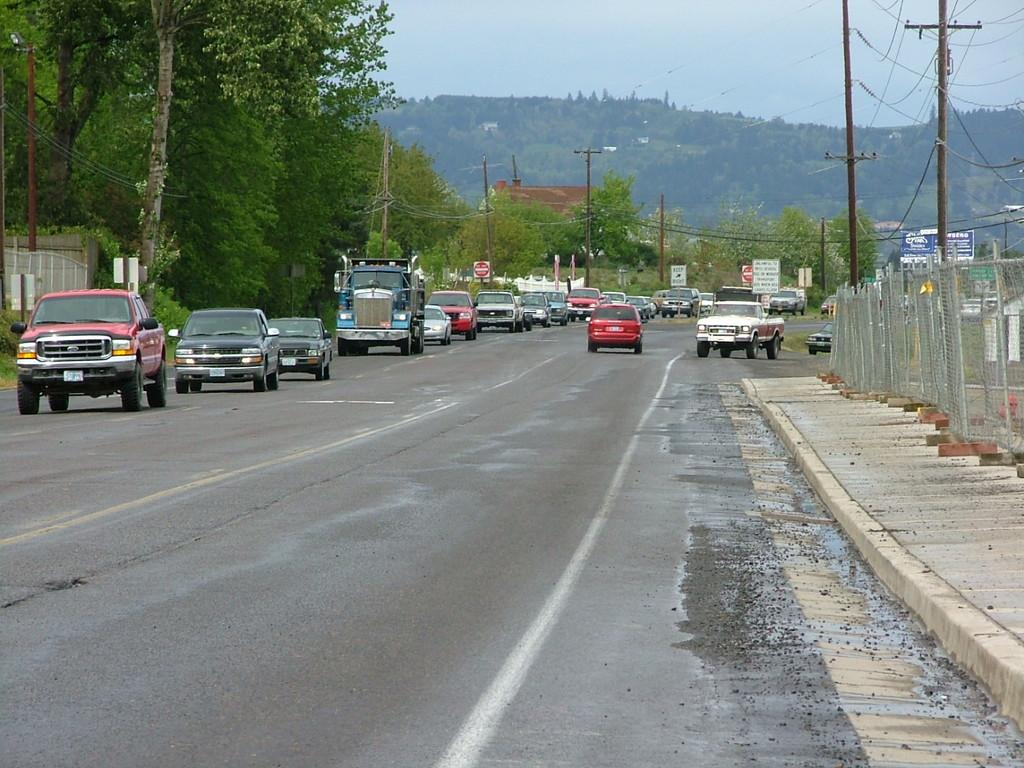What type of vehicles can be seen on the road in the image? There are motor vehicles on the road in the image. What structures are present in the image? Fences, electric poles, buildings, and trees are present in the image. What natural features can be seen in the image? Hills and the sky are visible in the image. What is the condition of the sky in the image? Clouds are present in the sky in the image. Can you tell me how many pears are hanging from the electric cables in the image? There are no pears present in the image; it features motor vehicles, fences, electric poles, buildings, trees, hills, and the sky with clouds. What type of laughter can be heard coming from the trees in the image? There is no laughter present in the image, as it is a still image and does not contain any sounds. 